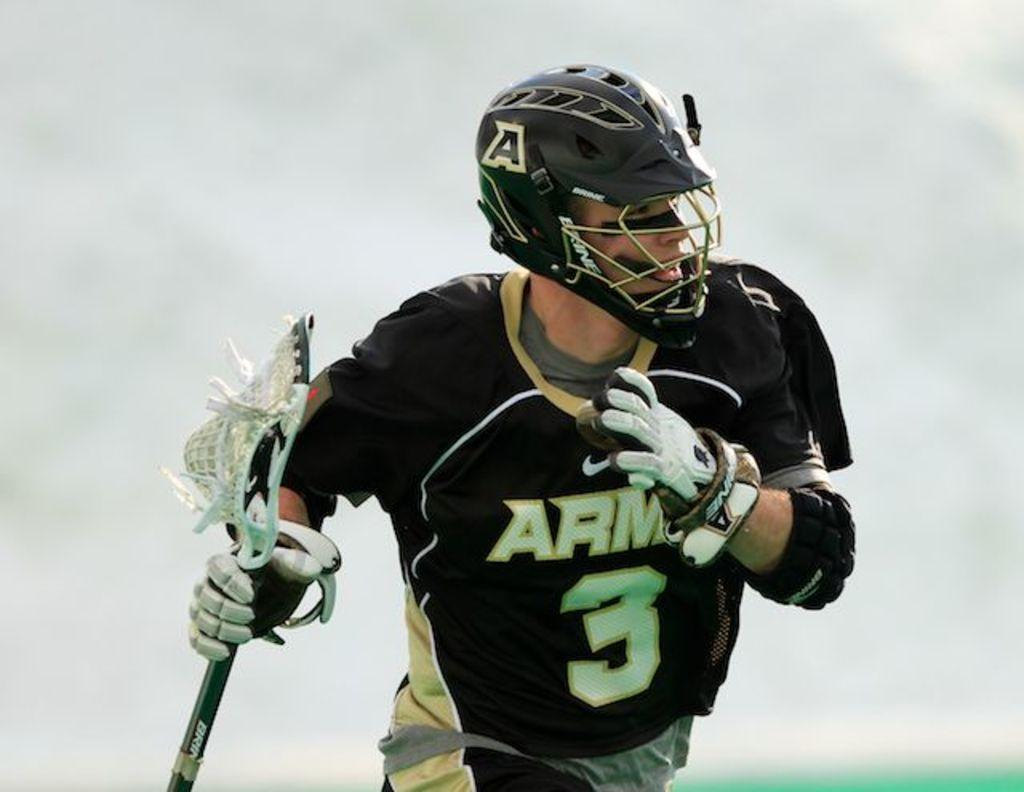What is the main subject of the image? There is a person in the image. What is the person holding in the image? The person is holding a lacrosse stick. What protective gear is the person wearing in the image? The person is wearing a helmet and gloves. What is the color of the background in the image? The background of the image is white. Are there any cars visible in the image? No, there are no cars present in the image. Is there a crate in the image? No, there is no crate present in the image. 